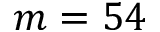Convert formula to latex. <formula><loc_0><loc_0><loc_500><loc_500>m = 5 4</formula> 